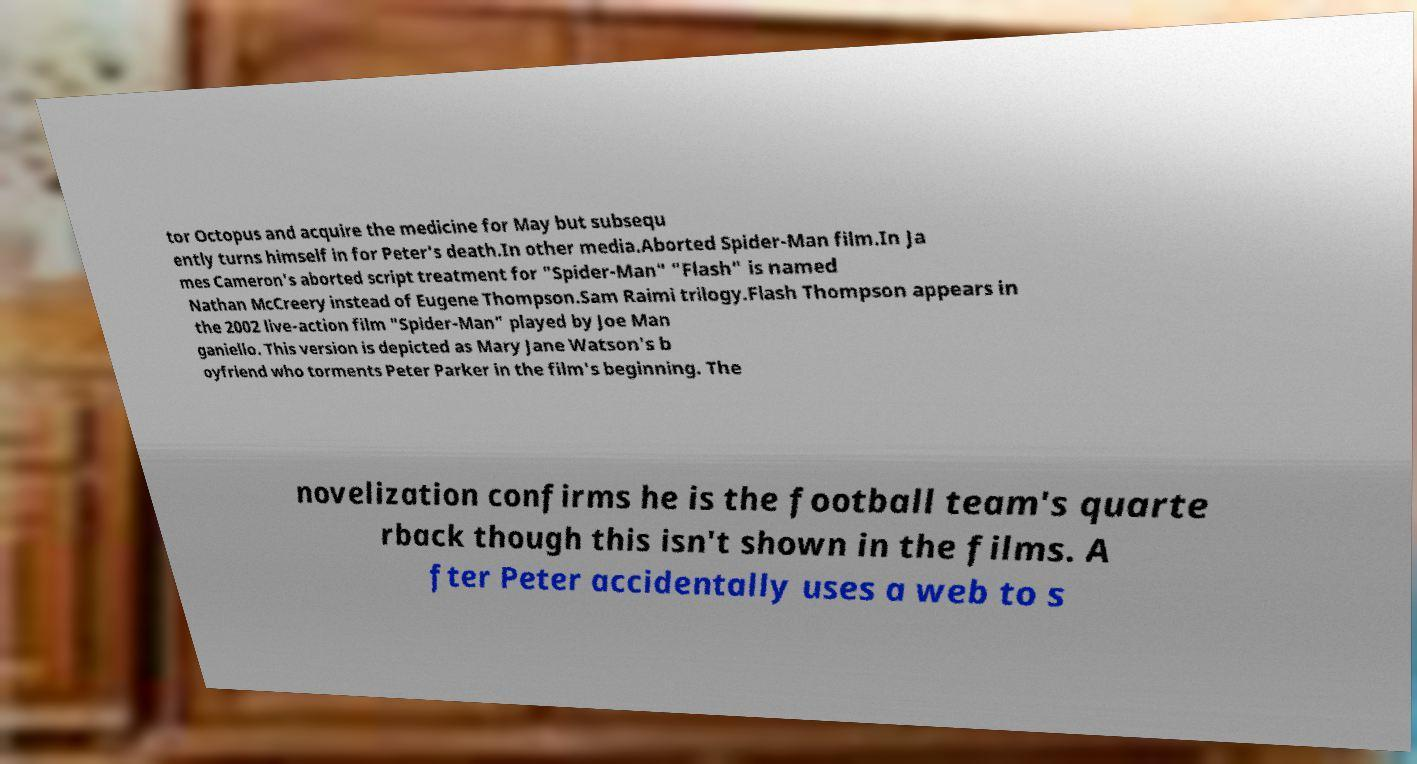Can you read and provide the text displayed in the image?This photo seems to have some interesting text. Can you extract and type it out for me? tor Octopus and acquire the medicine for May but subsequ ently turns himself in for Peter's death.In other media.Aborted Spider-Man film.In Ja mes Cameron's aborted script treatment for "Spider-Man" "Flash" is named Nathan McCreery instead of Eugene Thompson.Sam Raimi trilogy.Flash Thompson appears in the 2002 live-action film "Spider-Man" played by Joe Man ganiello. This version is depicted as Mary Jane Watson's b oyfriend who torments Peter Parker in the film's beginning. The novelization confirms he is the football team's quarte rback though this isn't shown in the films. A fter Peter accidentally uses a web to s 